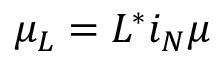<formula> <loc_0><loc_0><loc_500><loc_500>\mu _ { L } = L ^ { * } i _ { N } \mu</formula> 